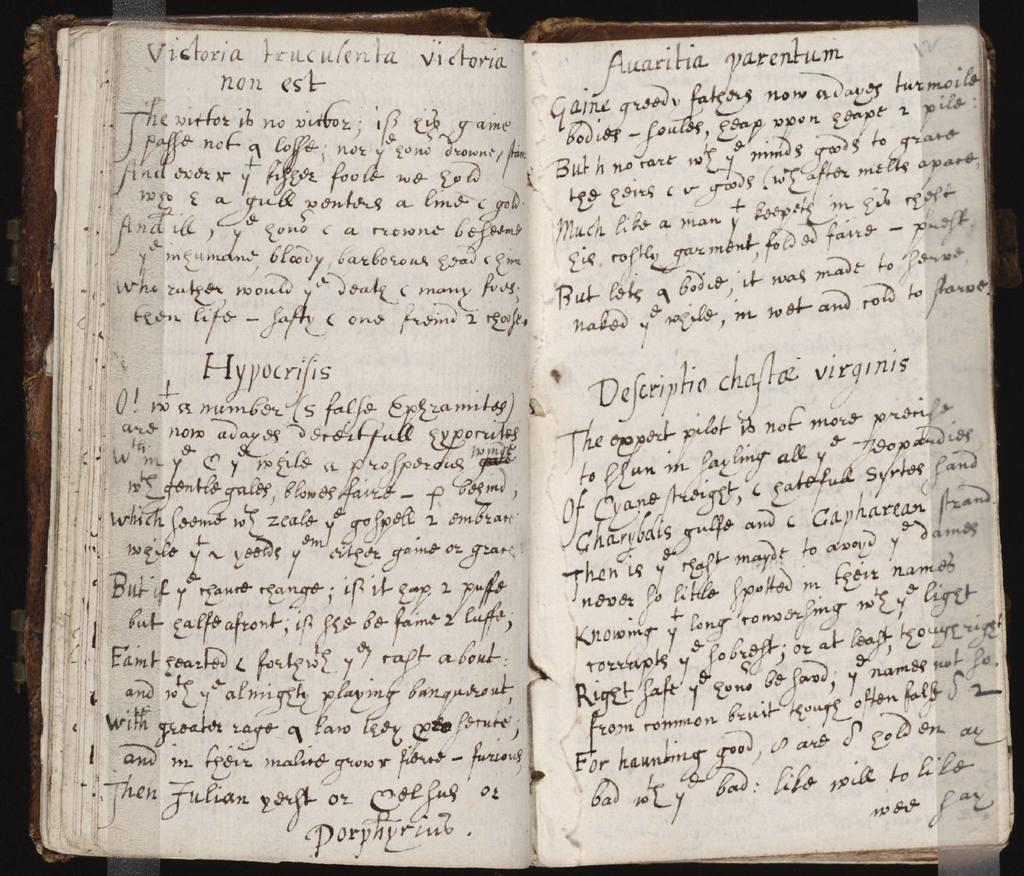<image>
Write a terse but informative summary of the picture. an antique book has a decsriptio chaftaz virginis inside 